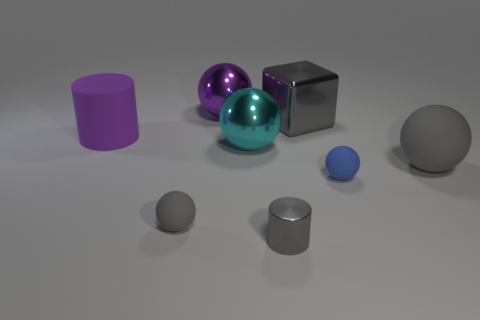How might the size of these objects compare to each other? The objects range in size noticeably. The large metallic cube appears to be the largest, followed by the purple cylinder and the teal sphere. The smaller silver cylinder, the two gray spheres, and particularly the small blue sphere seem much smaller by comparison. 